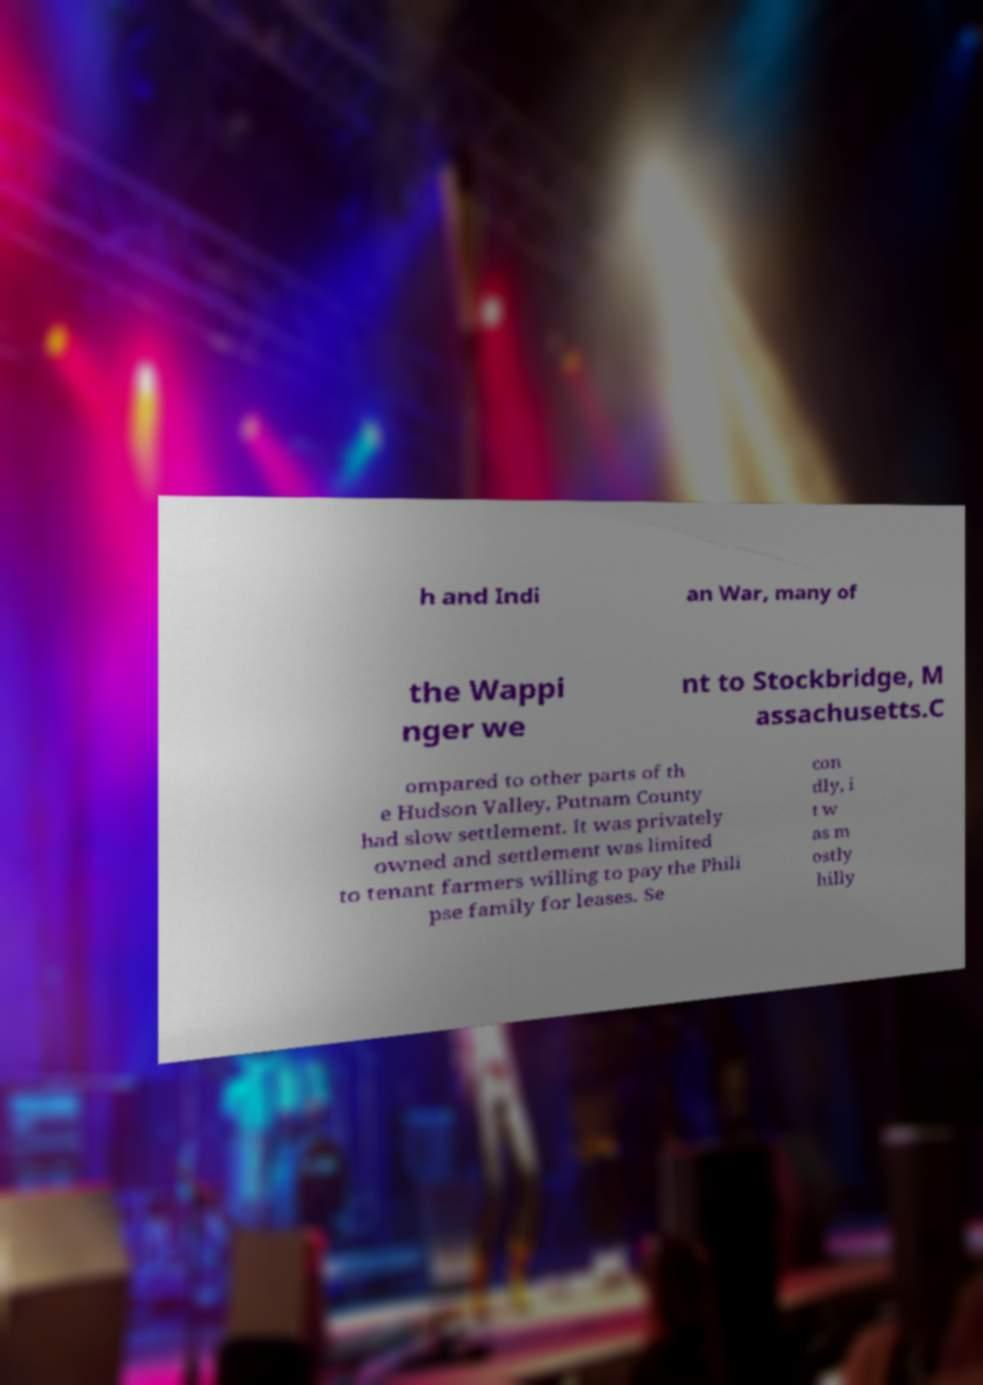There's text embedded in this image that I need extracted. Can you transcribe it verbatim? h and Indi an War, many of the Wappi nger we nt to Stockbridge, M assachusetts.C ompared to other parts of th e Hudson Valley, Putnam County had slow settlement. It was privately owned and settlement was limited to tenant farmers willing to pay the Phili pse family for leases. Se con dly, i t w as m ostly hilly 